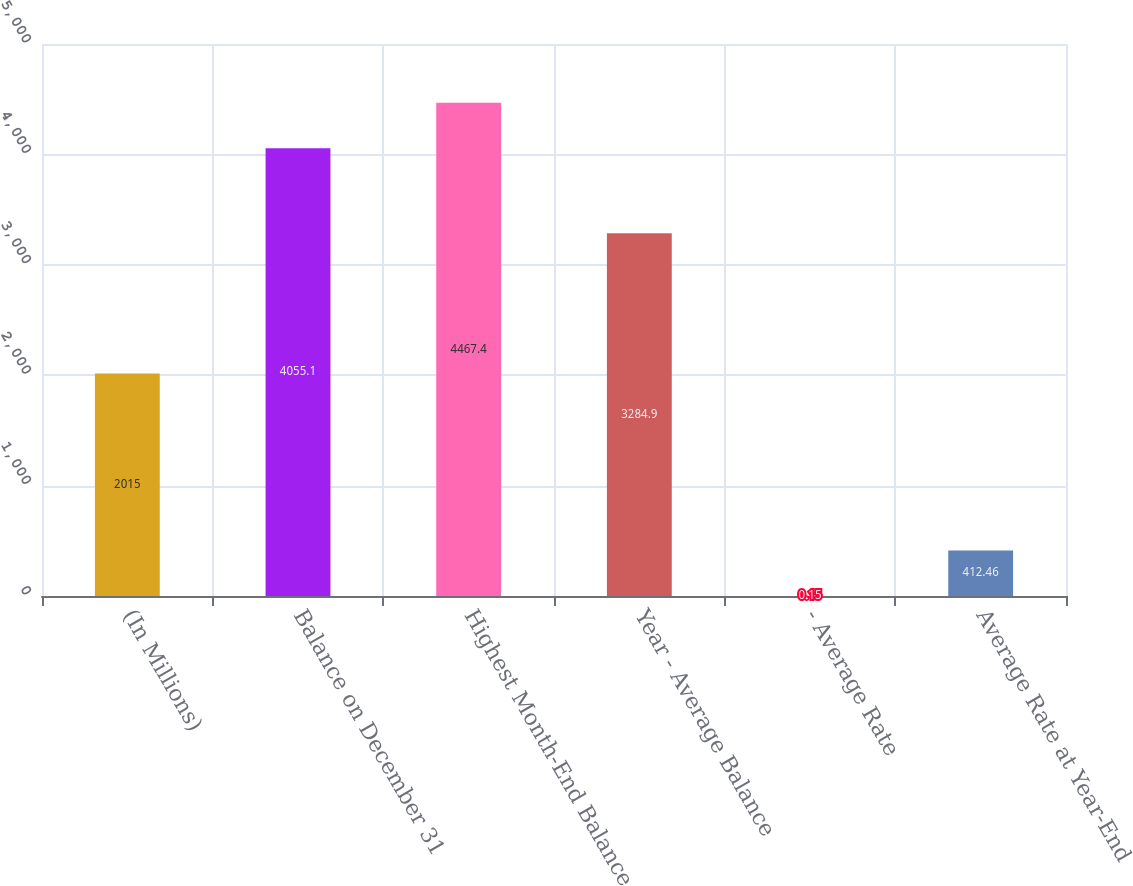Convert chart. <chart><loc_0><loc_0><loc_500><loc_500><bar_chart><fcel>(In Millions)<fcel>Balance on December 31<fcel>Highest Month-End Balance<fcel>Year - Average Balance<fcel>- Average Rate<fcel>Average Rate at Year-End<nl><fcel>2015<fcel>4055.1<fcel>4467.4<fcel>3284.9<fcel>0.15<fcel>412.46<nl></chart> 